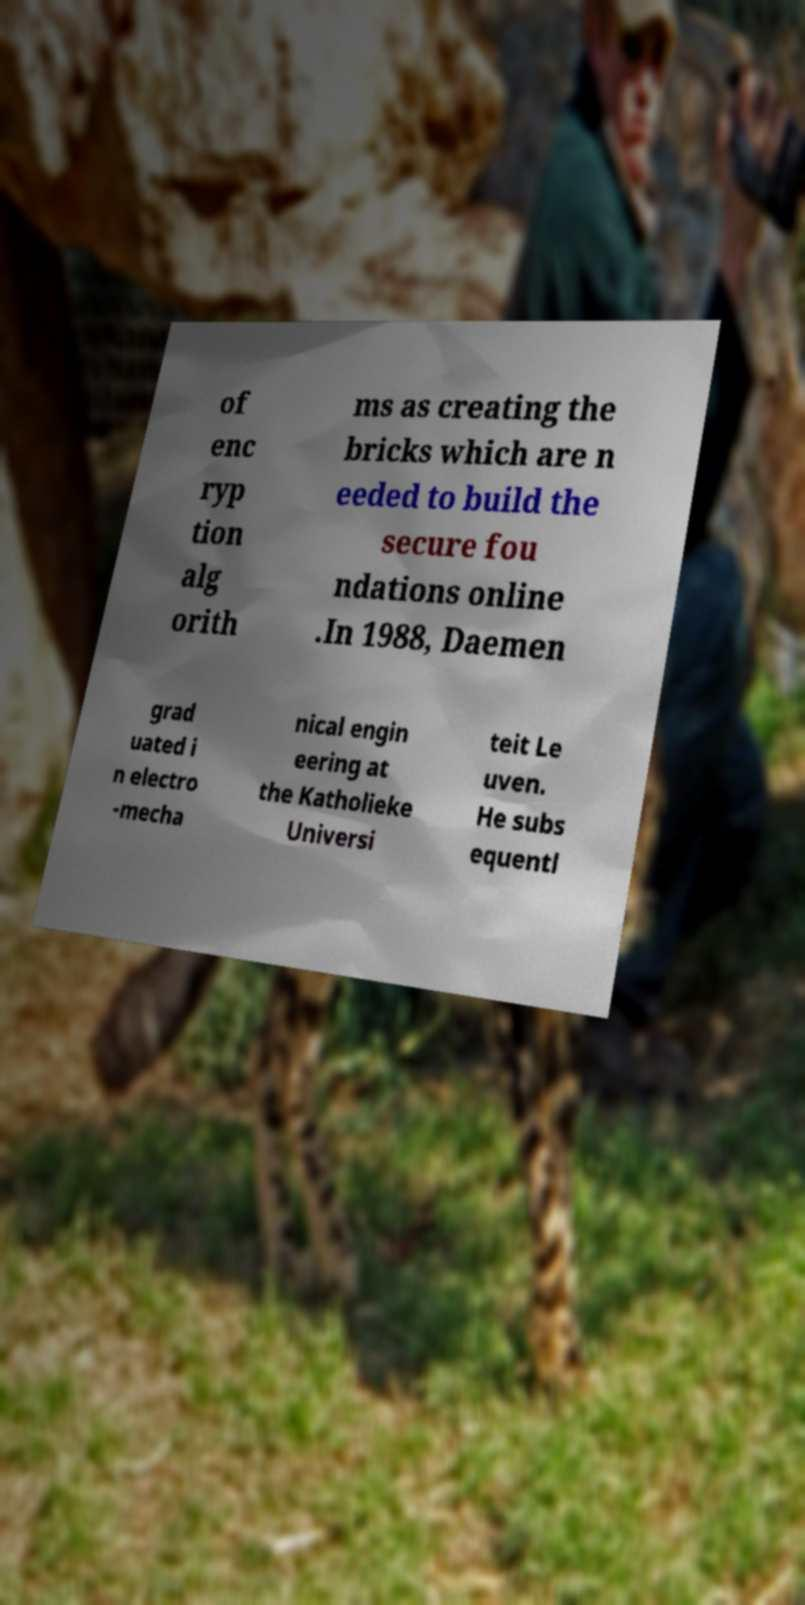Can you read and provide the text displayed in the image?This photo seems to have some interesting text. Can you extract and type it out for me? of enc ryp tion alg orith ms as creating the bricks which are n eeded to build the secure fou ndations online .In 1988, Daemen grad uated i n electro -mecha nical engin eering at the Katholieke Universi teit Le uven. He subs equentl 